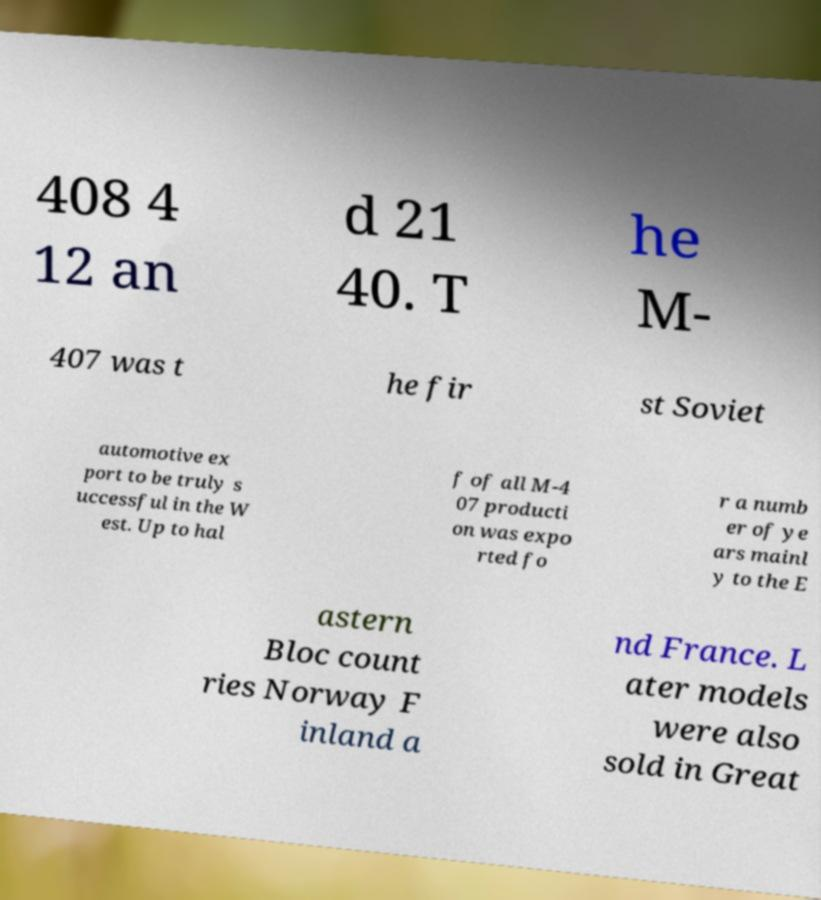Please read and relay the text visible in this image. What does it say? 408 4 12 an d 21 40. T he M- 407 was t he fir st Soviet automotive ex port to be truly s uccessful in the W est. Up to hal f of all M-4 07 producti on was expo rted fo r a numb er of ye ars mainl y to the E astern Bloc count ries Norway F inland a nd France. L ater models were also sold in Great 